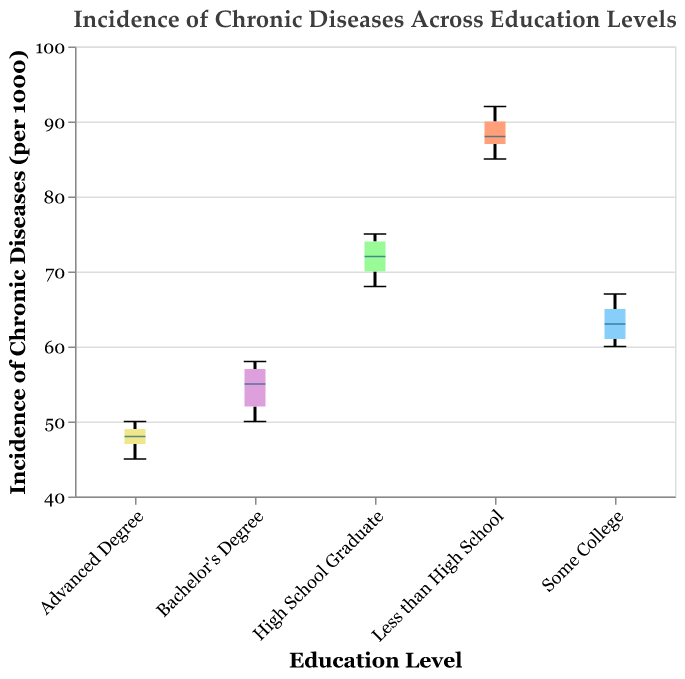What is the title of the figure? The title of the figure is usually displayed at the top of the chart. It reads "Incidence of Chronic Diseases Across Education Levels".
Answer: Incidence of Chronic Diseases Across Education Levels Which education level group has the highest median incidence of chronic diseases? By looking at the median lines inside the box plots, the group "Less than High School" has the highest median value.
Answer: Less than High School What are the axes labels? The x-axis is labeled "Education Level" and the y-axis is labeled "Incidence of Chronic Diseases (per 1000)".
Answer: Education Level (x-axis) and Incidence of Chronic Diseases (per 1000) (y-axis) What is the range of incidence values for individuals with an Advanced Degree? The highest incidence is 50 and the lowest is 45.
Answer: 45 to 50 How does the distribution of incidence values for "Some College" compare to "Bachelor's Degree"? "Some College" has a somewhat higher median and wider interquartile range compared to "Bachelor's Degree". The spread of values is also slightly larger.
Answer: Higher median, wider interquartile range, larger spread Which education level group shows the lowest variability in chronic disease incidence? The box plot for "Advanced Degree" is the narrowest, indicating it has the lowest variability.
Answer: Advanced Degree What is the interquartile range (IQR) for the "High School Graduate" group? The IQR is the difference between the third quartile (75th percentile) and the first quartile (25th percentile). For "High School Graduate," it ranges approximately from 70 to 74, so the IQR is 4.
Answer: 4 Which education level has the most outliers? By visual inspection, none of the education levels seem to have outliers in the provided box plots.
Answer: None What's the average incidence value for the group with the highest median incidence? For "Less than High School," sum up (85 + 90 + 88 + 92 + 87) = 442, then divide by 5. Average = 442 / 5 = 88.4
Answer: 88.4 Is there a trend in chronic disease incidence with increasing education level? Yes, the incidence of chronic diseases generally decreases as the education level increases.
Answer: Decreases with higher education levels 